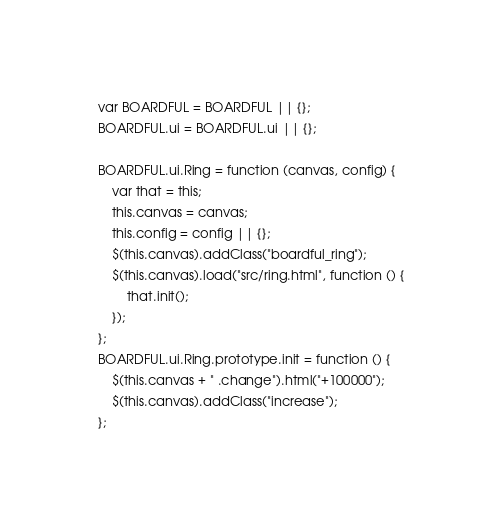<code> <loc_0><loc_0><loc_500><loc_500><_JavaScript_>var BOARDFUL = BOARDFUL || {};
BOARDFUL.ui = BOARDFUL.ui || {};

BOARDFUL.ui.Ring = function (canvas, config) {
	var that = this;
	this.canvas = canvas;
	this.config = config || {};
	$(this.canvas).addClass("boardful_ring");
	$(this.canvas).load("src/ring.html", function () {
		that.init();
	});
};
BOARDFUL.ui.Ring.prototype.init = function () {
	$(this.canvas + " .change").html("+100000");
	$(this.canvas).addClass("increase");
};</code> 